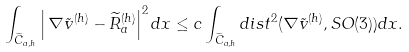Convert formula to latex. <formula><loc_0><loc_0><loc_500><loc_500>\int _ { \widetilde { C } _ { a , h } } \left | \, \nabla \tilde { v } ^ { ( h ) } - \widetilde { R } _ { a } ^ { ( h ) } \right | ^ { 2 } d x \leq c \int _ { \widetilde { C } _ { a , h } } d i s t ^ { 2 } ( \nabla \tilde { v } ^ { ( h ) } , S O ( 3 ) ) d x .</formula> 